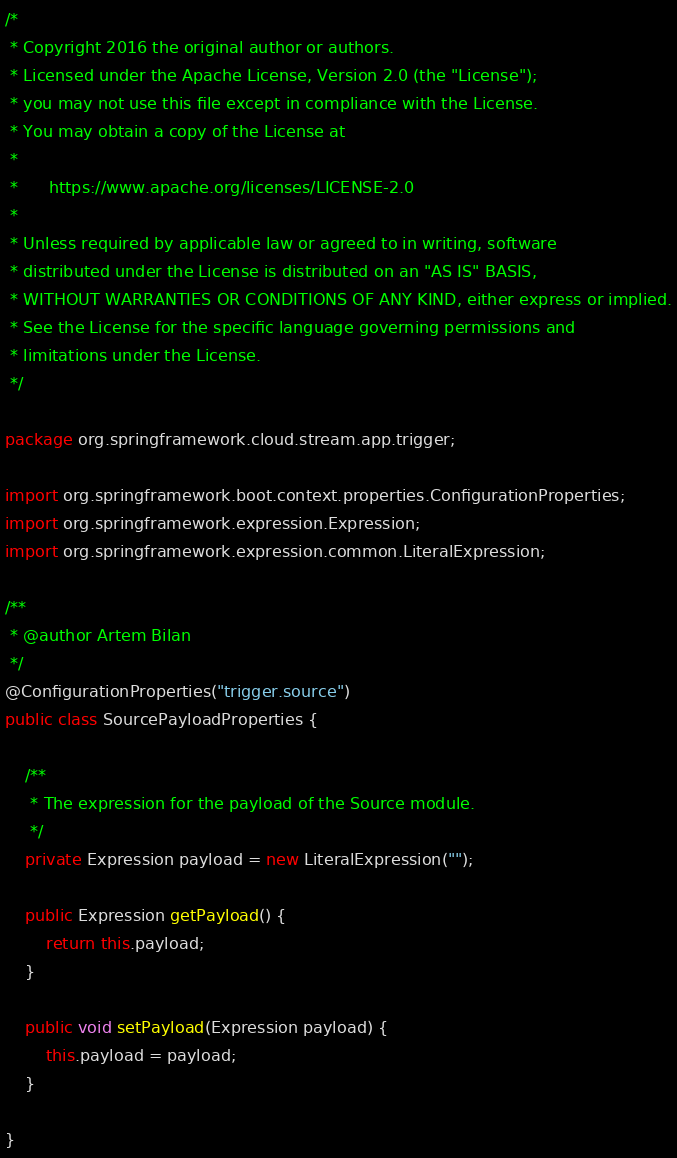Convert code to text. <code><loc_0><loc_0><loc_500><loc_500><_Java_>/*
 * Copyright 2016 the original author or authors.
 * Licensed under the Apache License, Version 2.0 (the "License");
 * you may not use this file except in compliance with the License.
 * You may obtain a copy of the License at
 *
 *      https://www.apache.org/licenses/LICENSE-2.0
 *
 * Unless required by applicable law or agreed to in writing, software
 * distributed under the License is distributed on an "AS IS" BASIS,
 * WITHOUT WARRANTIES OR CONDITIONS OF ANY KIND, either express or implied.
 * See the License for the specific language governing permissions and
 * limitations under the License.
 */

package org.springframework.cloud.stream.app.trigger;

import org.springframework.boot.context.properties.ConfigurationProperties;
import org.springframework.expression.Expression;
import org.springframework.expression.common.LiteralExpression;

/**
 * @author Artem Bilan
 */
@ConfigurationProperties("trigger.source")
public class SourcePayloadProperties {

	/**
	 * The expression for the payload of the Source module.
	 */
	private Expression payload = new LiteralExpression("");

	public Expression getPayload() {
		return this.payload;
	}

	public void setPayload(Expression payload) {
		this.payload = payload;
	}

}
</code> 